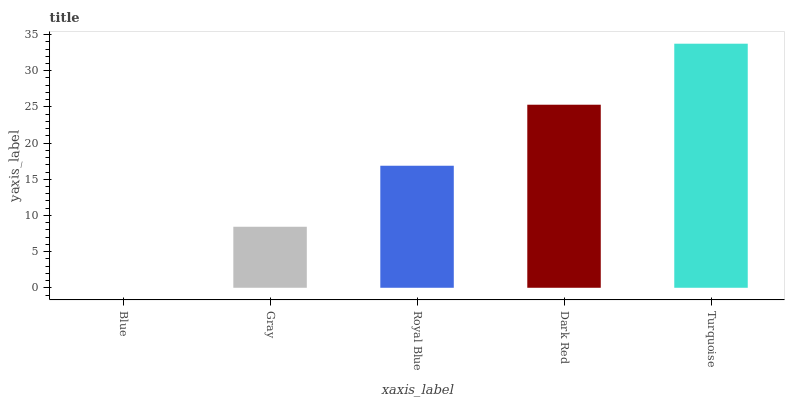Is Gray the minimum?
Answer yes or no. No. Is Gray the maximum?
Answer yes or no. No. Is Gray greater than Blue?
Answer yes or no. Yes. Is Blue less than Gray?
Answer yes or no. Yes. Is Blue greater than Gray?
Answer yes or no. No. Is Gray less than Blue?
Answer yes or no. No. Is Royal Blue the high median?
Answer yes or no. Yes. Is Royal Blue the low median?
Answer yes or no. Yes. Is Blue the high median?
Answer yes or no. No. Is Gray the low median?
Answer yes or no. No. 